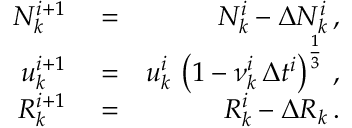Convert formula to latex. <formula><loc_0><loc_0><loc_500><loc_500>\begin{array} { r l r } { N _ { k } ^ { i + 1 } } & = } & { N _ { k } ^ { i } - \Delta N _ { k } ^ { i } \, , } \\ { u _ { k } ^ { i + 1 } } & = } & { u _ { k } ^ { i } \, \left ( 1 - \nu _ { k } ^ { i } \, \Delta t ^ { i } \right ) ^ { \frac { 1 } { 3 } } \, , } \\ { R _ { k } ^ { i + 1 } } & = } & { R _ { k } ^ { i } - \Delta R _ { k } \, . } \end{array}</formula> 